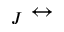Convert formula to latex. <formula><loc_0><loc_0><loc_500><loc_500>_ { J } \leftrightarrow</formula> 